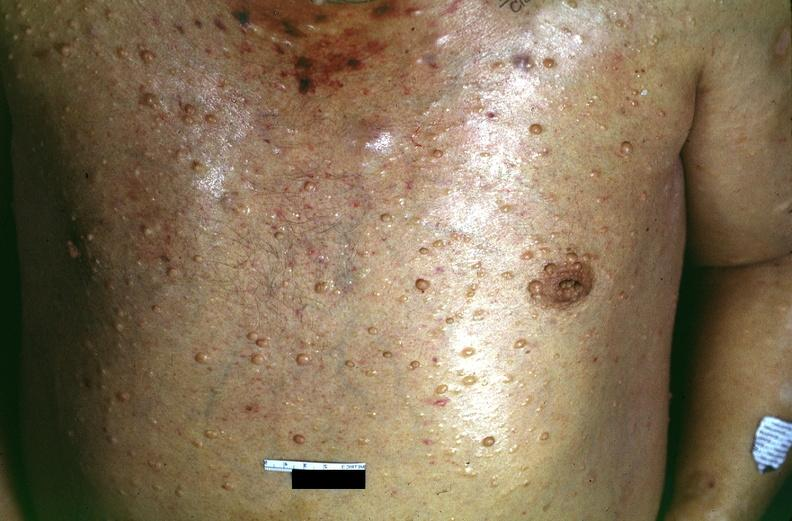what does this image show?
Answer the question using a single word or phrase. Skin 